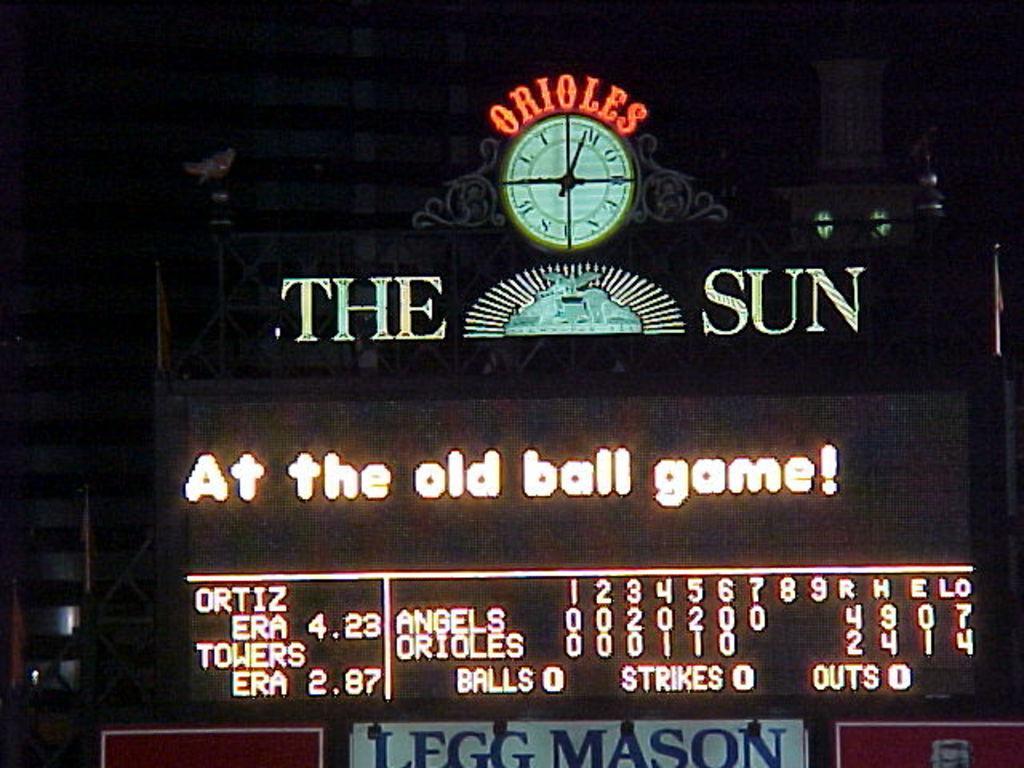How would you summarize this image in a sentence or two? In the image there is a building with a clock in the middle and below there is a scroll board. 